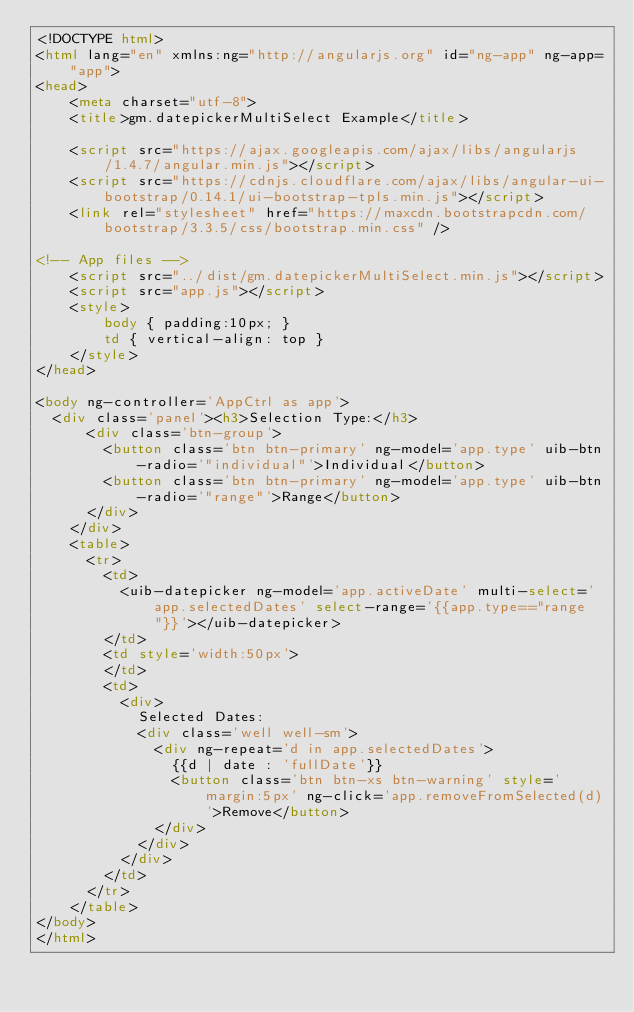Convert code to text. <code><loc_0><loc_0><loc_500><loc_500><_HTML_><!DOCTYPE html>
<html lang="en" xmlns:ng="http://angularjs.org" id="ng-app" ng-app="app">
<head>
	<meta charset="utf-8">
    <title>gm.datepickerMultiSelect Example</title>
	
	<script src="https://ajax.googleapis.com/ajax/libs/angularjs/1.4.7/angular.min.js"></script>
	<script src="https://cdnjs.cloudflare.com/ajax/libs/angular-ui-bootstrap/0.14.1/ui-bootstrap-tpls.min.js"></script>
	<link rel="stylesheet" href="https://maxcdn.bootstrapcdn.com/bootstrap/3.3.5/css/bootstrap.min.css" />
	
<!-- App files -->
	<script src="../dist/gm.datepickerMultiSelect.min.js"></script>
	<script src="app.js"></script>
	<style>
		body { padding:10px; }
		td { vertical-align: top }
	</style>
</head>

<body ng-controller='AppCtrl as app'>
  <div class='panel'><h3>Selection Type:</h3>
      <div class='btn-group'>
        <button class='btn btn-primary' ng-model='app.type' uib-btn-radio='"individual"'>Individual</button>
        <button class='btn btn-primary' ng-model='app.type' uib-btn-radio='"range"'>Range</button>
      </div>
    </div>
    <table>
      <tr>
        <td>
          <uib-datepicker ng-model='app.activeDate' multi-select='app.selectedDates' select-range='{{app.type=="range"}}'></uib-datepicker>
        </td>
        <td style='width:50px'>
        </td>
        <td>
          <div>
            Selected Dates:
            <div class='well well-sm'>
              <div ng-repeat='d in app.selectedDates'>
                {{d | date : 'fullDate'}}
                <button class='btn btn-xs btn-warning' style='margin:5px' ng-click='app.removeFromSelected(d)'>Remove</button>
              </div>
            </div>
          </div>
        </td>
      </tr>
    </table>
</body>
</html></code> 